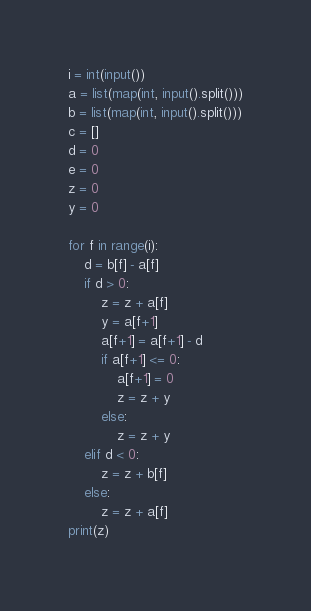Convert code to text. <code><loc_0><loc_0><loc_500><loc_500><_Python_>i = int(input())
a = list(map(int, input().split()))
b = list(map(int, input().split()))
c = []
d = 0
e = 0
z = 0
y = 0

for f in range(i):
    d = b[f] - a[f]
    if d > 0:
        z = z + a[f]
        y = a[f+1]
        a[f+1] = a[f+1] - d
        if a[f+1] <= 0:
            a[f+1] = 0
            z = z + y
        else:
            z = z + y
    elif d < 0:
        z = z + b[f]
    else:
        z = z + a[f]
print(z)</code> 